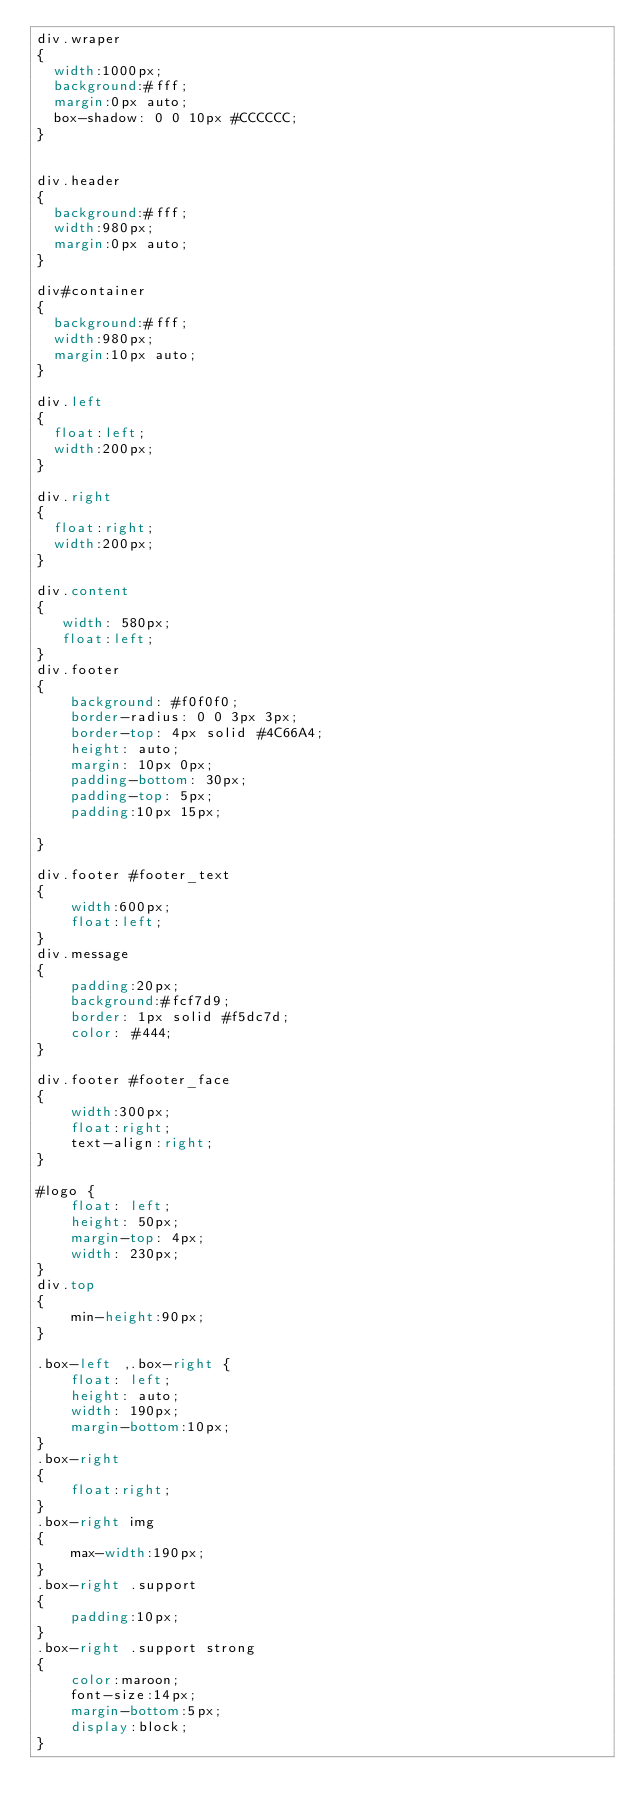Convert code to text. <code><loc_0><loc_0><loc_500><loc_500><_CSS_>div.wraper
{
  width:1000px;
  background:#fff;
  margin:0px auto;
  box-shadow: 0 0 10px #CCCCCC;
}


div.header
{
  background:#fff;
  width:980px;
  margin:0px auto;
}

div#container
{
  background:#fff;
  width:980px;
  margin:10px auto;
}

div.left
{
  float:left;
  width:200px;
}

div.right
{
  float:right;
  width:200px;
}

div.content
{
   width: 580px;
   float:left;
}
div.footer
{
	background: #f0f0f0;
    border-radius: 0 0 3px 3px;
    border-top: 4px solid #4C66A4;
    height: auto;
    margin: 10px 0px;
    padding-bottom: 30px;
    padding-top: 5px;
	padding:10px 15px;
	
}

div.footer #footer_text
{
	width:600px;
	float:left;
}
div.message
{
	padding:20px;
	background:#fcf7d9;
	border: 1px solid #f5dc7d;
    color: #444;
}

div.footer #footer_face
{
	width:300px;
	float:right;
	text-align:right;
}

#logo {
    float: left;
    height: 50px;
    margin-top: 4px;
    width: 230px;
}
div.top
{
	min-height:90px;
}

.box-left ,.box-right {
    float: left;
    height: auto;
    width: 190px;
    margin-bottom:10px;
}
.box-right
{
	float:right;
}
.box-right img
{
	max-width:190px;
}
.box-right .support
{
	padding:10px;
}
.box-right .support strong
{
	color:maroon;
	font-size:14px;
	margin-bottom:5px;
	display:block;
}</code> 